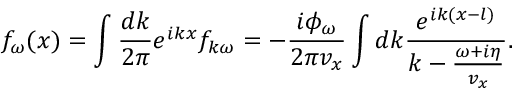Convert formula to latex. <formula><loc_0><loc_0><loc_500><loc_500>f _ { \omega } ( x ) = \int \frac { d k } { 2 \pi } e ^ { i k x } f _ { k \omega } = - \frac { i \phi _ { \omega } } { 2 \pi v _ { x } } \int d k \frac { e ^ { i k ( x - l ) } } { k - \frac { \omega + i \eta } { v _ { x } } } .</formula> 